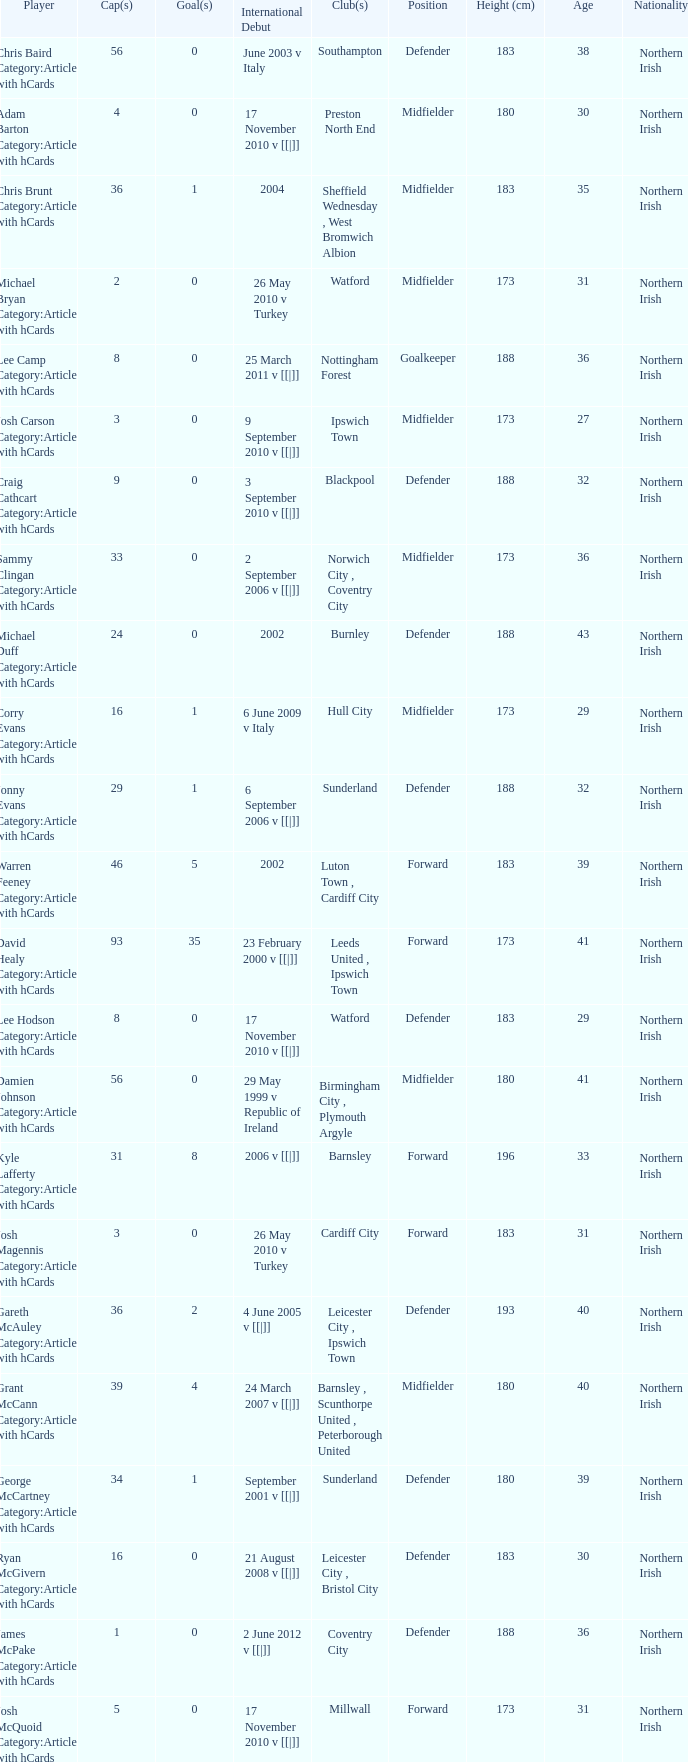How many players had 8 goals? 1.0. 